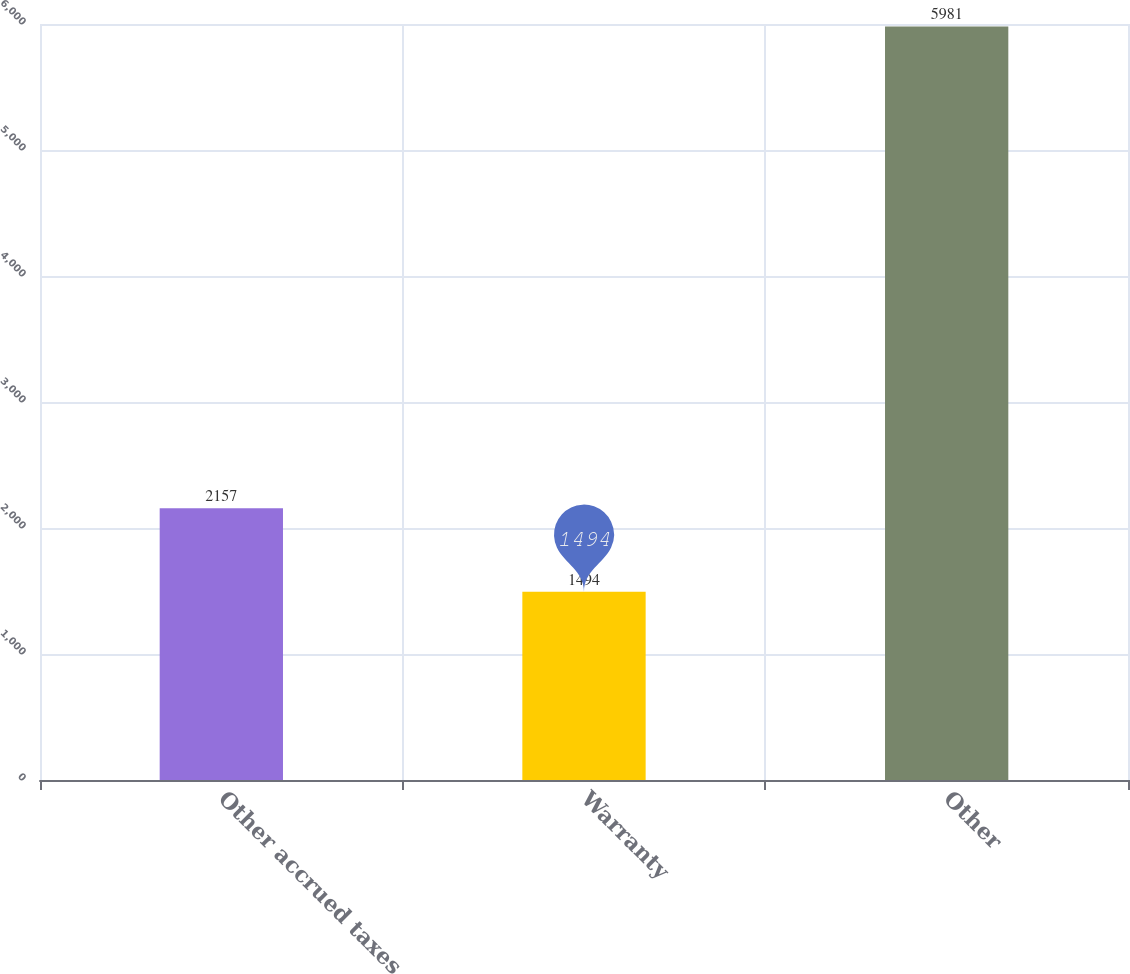Convert chart. <chart><loc_0><loc_0><loc_500><loc_500><bar_chart><fcel>Other accrued taxes<fcel>Warranty<fcel>Other<nl><fcel>2157<fcel>1494<fcel>5981<nl></chart> 